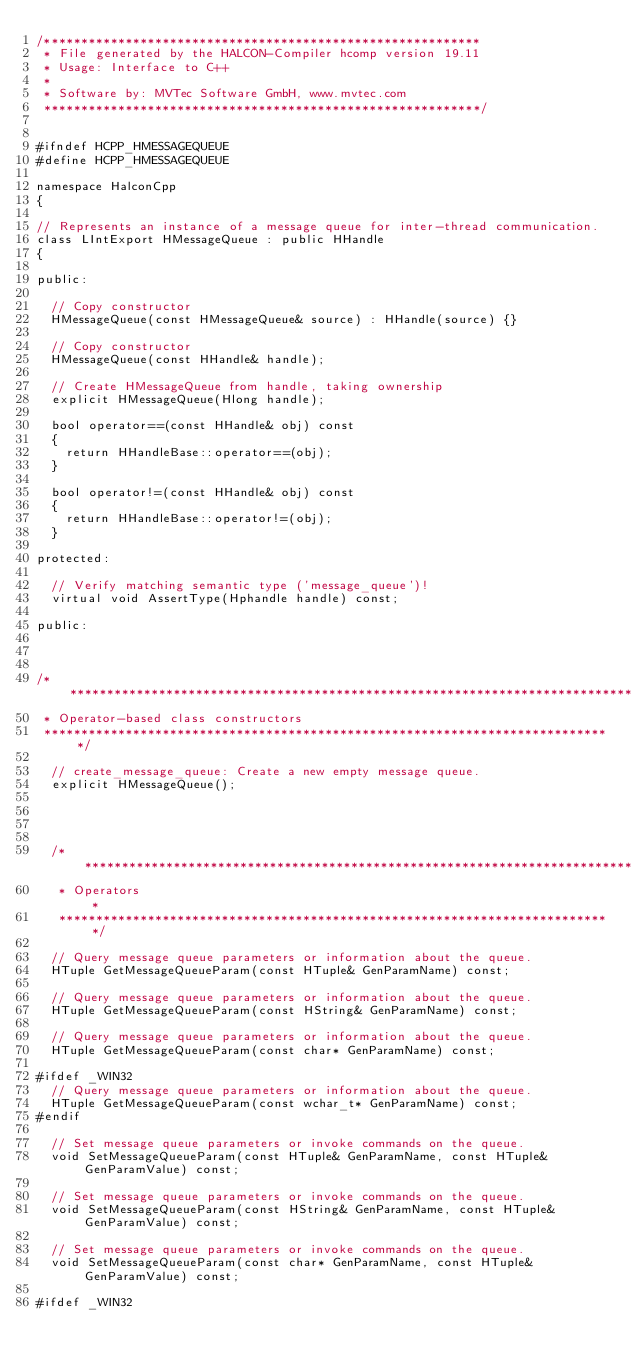<code> <loc_0><loc_0><loc_500><loc_500><_C_>/***********************************************************
 * File generated by the HALCON-Compiler hcomp version 19.11
 * Usage: Interface to C++
 *
 * Software by: MVTec Software GmbH, www.mvtec.com
 ***********************************************************/


#ifndef HCPP_HMESSAGEQUEUE
#define HCPP_HMESSAGEQUEUE

namespace HalconCpp
{

// Represents an instance of a message queue for inter-thread communication.
class LIntExport HMessageQueue : public HHandle
{

public:

  // Copy constructor
  HMessageQueue(const HMessageQueue& source) : HHandle(source) {}

  // Copy constructor
  HMessageQueue(const HHandle& handle);

  // Create HMessageQueue from handle, taking ownership
  explicit HMessageQueue(Hlong handle);

  bool operator==(const HHandle& obj) const
  {
    return HHandleBase::operator==(obj);
  }

  bool operator!=(const HHandle& obj) const
  {
    return HHandleBase::operator!=(obj);
  }

protected:

  // Verify matching semantic type ('message_queue')!
  virtual void AssertType(Hphandle handle) const;

public:



/*****************************************************************************
 * Operator-based class constructors
 *****************************************************************************/

  // create_message_queue: Create a new empty message queue.
  explicit HMessageQueue();




  /***************************************************************************
   * Operators                                                               *
   ***************************************************************************/

  // Query message queue parameters or information about the queue.
  HTuple GetMessageQueueParam(const HTuple& GenParamName) const;

  // Query message queue parameters or information about the queue.
  HTuple GetMessageQueueParam(const HString& GenParamName) const;

  // Query message queue parameters or information about the queue.
  HTuple GetMessageQueueParam(const char* GenParamName) const;

#ifdef _WIN32
  // Query message queue parameters or information about the queue.
  HTuple GetMessageQueueParam(const wchar_t* GenParamName) const;
#endif

  // Set message queue parameters or invoke commands on the queue.
  void SetMessageQueueParam(const HTuple& GenParamName, const HTuple& GenParamValue) const;

  // Set message queue parameters or invoke commands on the queue.
  void SetMessageQueueParam(const HString& GenParamName, const HTuple& GenParamValue) const;

  // Set message queue parameters or invoke commands on the queue.
  void SetMessageQueueParam(const char* GenParamName, const HTuple& GenParamValue) const;

#ifdef _WIN32</code> 